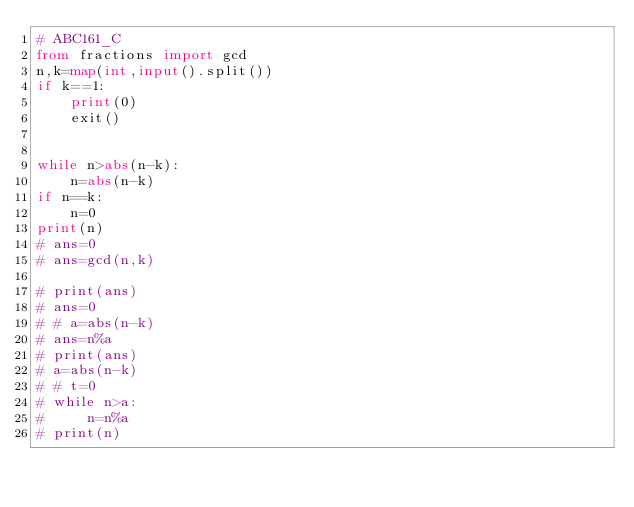Convert code to text. <code><loc_0><loc_0><loc_500><loc_500><_Python_># ABC161_C
from fractions import gcd
n,k=map(int,input().split())
if k==1:
    print(0)
    exit()


while n>abs(n-k):
    n=abs(n-k)
if n==k:
    n=0
print(n)
# ans=0
# ans=gcd(n,k)

# print(ans)
# ans=0
# # a=abs(n-k)
# ans=n%a
# print(ans)
# a=abs(n-k)
# # t=0
# while n>a:
#     n=n%a
# print(n)


</code> 